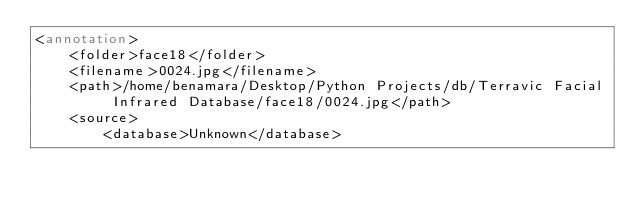<code> <loc_0><loc_0><loc_500><loc_500><_XML_><annotation>
	<folder>face18</folder>
	<filename>0024.jpg</filename>
	<path>/home/benamara/Desktop/Python Projects/db/Terravic Facial Infrared Database/face18/0024.jpg</path>
	<source>
		<database>Unknown</database></code> 